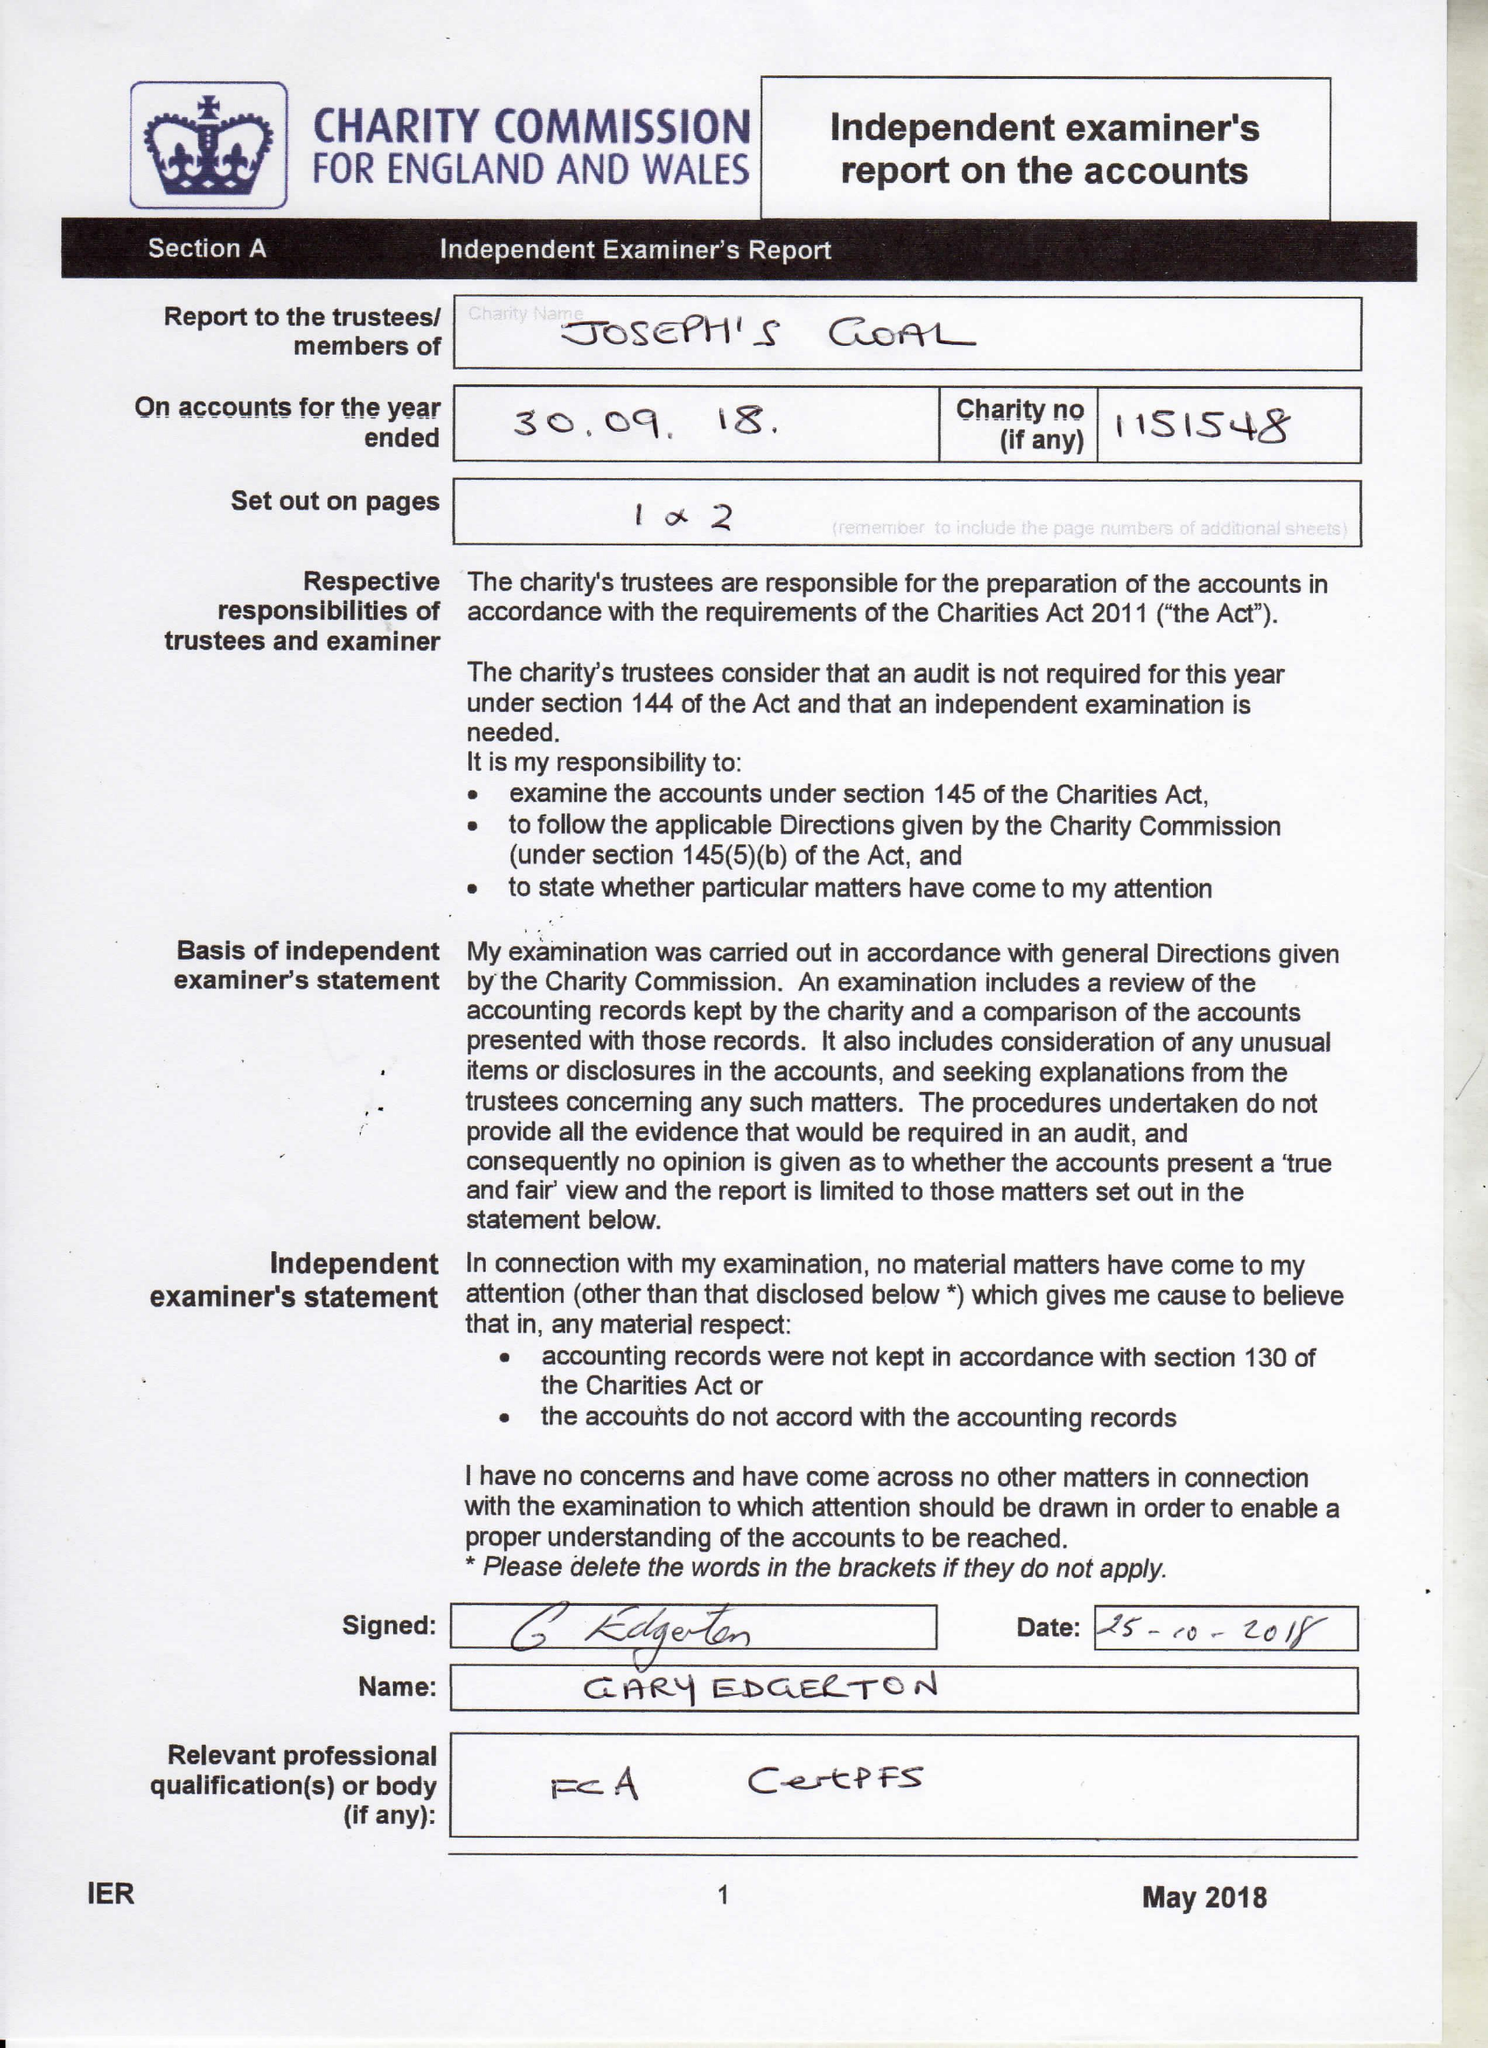What is the value for the address__post_town?
Answer the question using a single word or phrase. WIGAN 